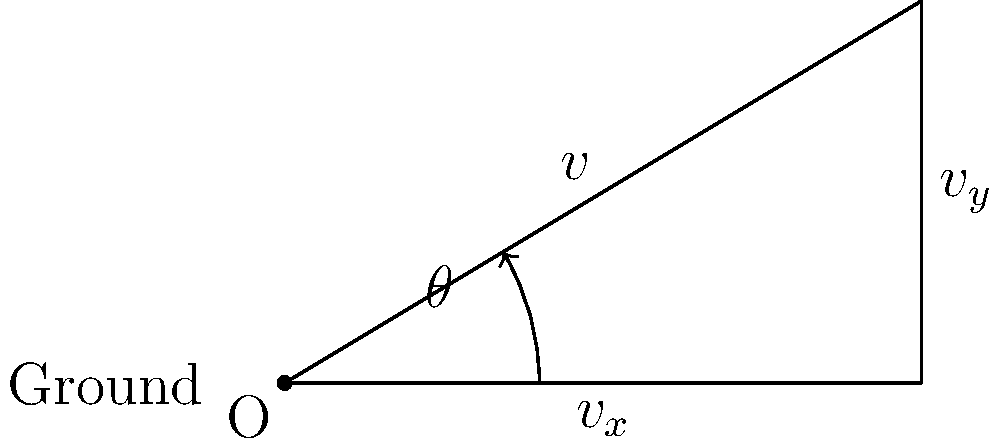As a sports commentator, you're analyzing a crucial soccer kick. The kick needs to clear a 3-meter high wall 5 meters away. What is the optimal angle $\theta$ for the kick to just clear the wall, assuming the ball is kicked from ground level with a constant initial velocity? Let's approach this step-by-step:

1) We can use the equation of projectile motion:
   $$y = x \tan \theta - \frac{gx^2}{2v^2\cos^2\theta}$$
   where $g$ is the acceleration due to gravity (9.8 m/s²).

2) We know that when $x = 5$ m, $y = 3$ m. Substituting these values:
   $$3 = 5 \tan \theta - \frac{9.8 \cdot 5^2}{2v^2\cos^2\theta}$$

3) For the optimal angle, we want the ball to just clear the wall. This means the vertex of the parabola should be at $(5,3)$. The time to reach this point is half the total flight time.

4) The time to reach the highest point is given by:
   $$t = \frac{v\sin\theta}{g}$$

5) The horizontal distance covered in this time is:
   $$x = v\cos\theta \cdot \frac{v\sin\theta}{g} = \frac{v^2\sin2\theta}{2g}$$

6) We want this distance to be 5 m, so:
   $$5 = \frac{v^2\sin2\theta}{2g}$$

7) Solving for $\theta$:
   $$\sin2\theta = \frac{10g}{v^2}$$
   $$\theta = \frac{1}{2}\arcsin(\frac{10g}{v^2})$$

8) The optimal angle is when $\sin2\theta = 1$, which occurs when $2\theta = 90°$ or $\theta = 45°$.

Therefore, the optimal angle for the kick is 45°.
Answer: 45° 